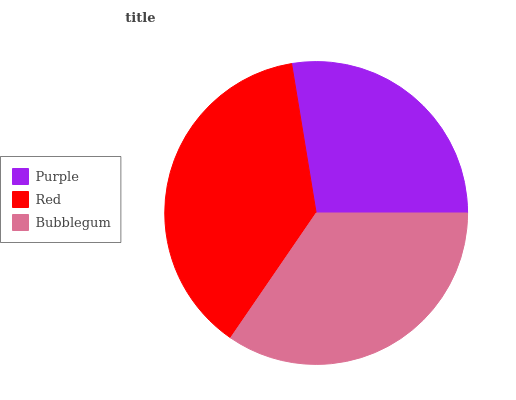Is Purple the minimum?
Answer yes or no. Yes. Is Red the maximum?
Answer yes or no. Yes. Is Bubblegum the minimum?
Answer yes or no. No. Is Bubblegum the maximum?
Answer yes or no. No. Is Red greater than Bubblegum?
Answer yes or no. Yes. Is Bubblegum less than Red?
Answer yes or no. Yes. Is Bubblegum greater than Red?
Answer yes or no. No. Is Red less than Bubblegum?
Answer yes or no. No. Is Bubblegum the high median?
Answer yes or no. Yes. Is Bubblegum the low median?
Answer yes or no. Yes. Is Purple the high median?
Answer yes or no. No. Is Red the low median?
Answer yes or no. No. 